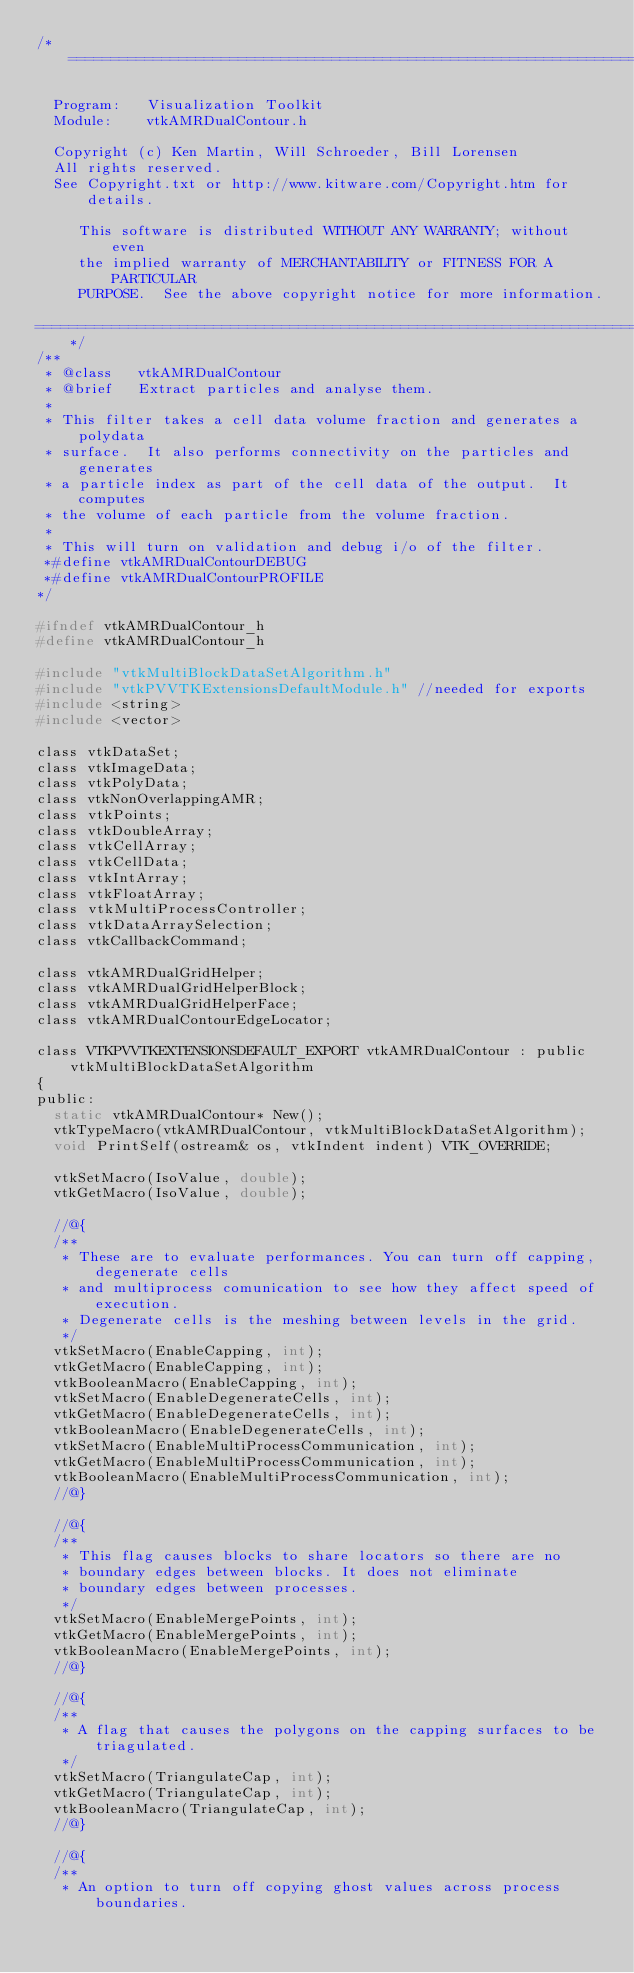Convert code to text. <code><loc_0><loc_0><loc_500><loc_500><_C_>/*=========================================================================

  Program:   Visualization Toolkit
  Module:    vtkAMRDualContour.h

  Copyright (c) Ken Martin, Will Schroeder, Bill Lorensen
  All rights reserved.
  See Copyright.txt or http://www.kitware.com/Copyright.htm for details.

     This software is distributed WITHOUT ANY WARRANTY; without even
     the implied warranty of MERCHANTABILITY or FITNESS FOR A PARTICULAR
     PURPOSE.  See the above copyright notice for more information.

=========================================================================*/
/**
 * @class   vtkAMRDualContour
 * @brief   Extract particles and analyse them.
 *
 * This filter takes a cell data volume fraction and generates a polydata
 * surface.  It also performs connectivity on the particles and generates
 * a particle index as part of the cell data of the output.  It computes
 * the volume of each particle from the volume fraction.
 *
 * This will turn on validation and debug i/o of the filter.
 *#define vtkAMRDualContourDEBUG
 *#define vtkAMRDualContourPROFILE
*/

#ifndef vtkAMRDualContour_h
#define vtkAMRDualContour_h

#include "vtkMultiBlockDataSetAlgorithm.h"
#include "vtkPVVTKExtensionsDefaultModule.h" //needed for exports
#include <string>
#include <vector>

class vtkDataSet;
class vtkImageData;
class vtkPolyData;
class vtkNonOverlappingAMR;
class vtkPoints;
class vtkDoubleArray;
class vtkCellArray;
class vtkCellData;
class vtkIntArray;
class vtkFloatArray;
class vtkMultiProcessController;
class vtkDataArraySelection;
class vtkCallbackCommand;

class vtkAMRDualGridHelper;
class vtkAMRDualGridHelperBlock;
class vtkAMRDualGridHelperFace;
class vtkAMRDualContourEdgeLocator;

class VTKPVVTKEXTENSIONSDEFAULT_EXPORT vtkAMRDualContour : public vtkMultiBlockDataSetAlgorithm
{
public:
  static vtkAMRDualContour* New();
  vtkTypeMacro(vtkAMRDualContour, vtkMultiBlockDataSetAlgorithm);
  void PrintSelf(ostream& os, vtkIndent indent) VTK_OVERRIDE;

  vtkSetMacro(IsoValue, double);
  vtkGetMacro(IsoValue, double);

  //@{
  /**
   * These are to evaluate performances. You can turn off capping, degenerate cells
   * and multiprocess comunication to see how they affect speed of execution.
   * Degenerate cells is the meshing between levels in the grid.
   */
  vtkSetMacro(EnableCapping, int);
  vtkGetMacro(EnableCapping, int);
  vtkBooleanMacro(EnableCapping, int);
  vtkSetMacro(EnableDegenerateCells, int);
  vtkGetMacro(EnableDegenerateCells, int);
  vtkBooleanMacro(EnableDegenerateCells, int);
  vtkSetMacro(EnableMultiProcessCommunication, int);
  vtkGetMacro(EnableMultiProcessCommunication, int);
  vtkBooleanMacro(EnableMultiProcessCommunication, int);
  //@}

  //@{
  /**
   * This flag causes blocks to share locators so there are no
   * boundary edges between blocks. It does not eliminate
   * boundary edges between processes.
   */
  vtkSetMacro(EnableMergePoints, int);
  vtkGetMacro(EnableMergePoints, int);
  vtkBooleanMacro(EnableMergePoints, int);
  //@}

  //@{
  /**
   * A flag that causes the polygons on the capping surfaces to be triagulated.
   */
  vtkSetMacro(TriangulateCap, int);
  vtkGetMacro(TriangulateCap, int);
  vtkBooleanMacro(TriangulateCap, int);
  //@}

  //@{
  /**
   * An option to turn off copying ghost values across process boundaries.</code> 